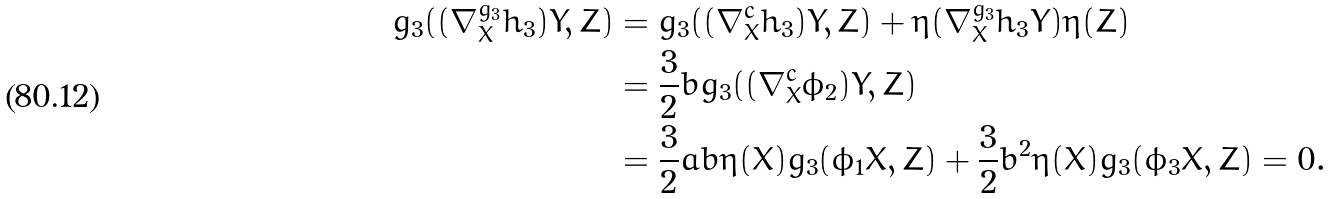<formula> <loc_0><loc_0><loc_500><loc_500>g _ { 3 } ( ( \nabla ^ { g _ { 3 } } _ { X } h _ { 3 } ) Y , Z ) & = g _ { 3 } ( ( \nabla ^ { c } _ { X } h _ { 3 } ) Y , Z ) + \eta ( \nabla ^ { g _ { 3 } } _ { X } h _ { 3 } Y ) \eta ( Z ) \\ & = \frac { 3 } { 2 } b g _ { 3 } ( ( \nabla ^ { c } _ { X } \phi _ { 2 } ) Y , Z ) \\ & = \frac { 3 } { 2 } a b \eta ( X ) g _ { 3 } ( \phi _ { 1 } X , Z ) + \frac { 3 } { 2 } b ^ { 2 } \eta ( X ) g _ { 3 } ( \phi _ { 3 } X , Z ) = 0 .</formula> 